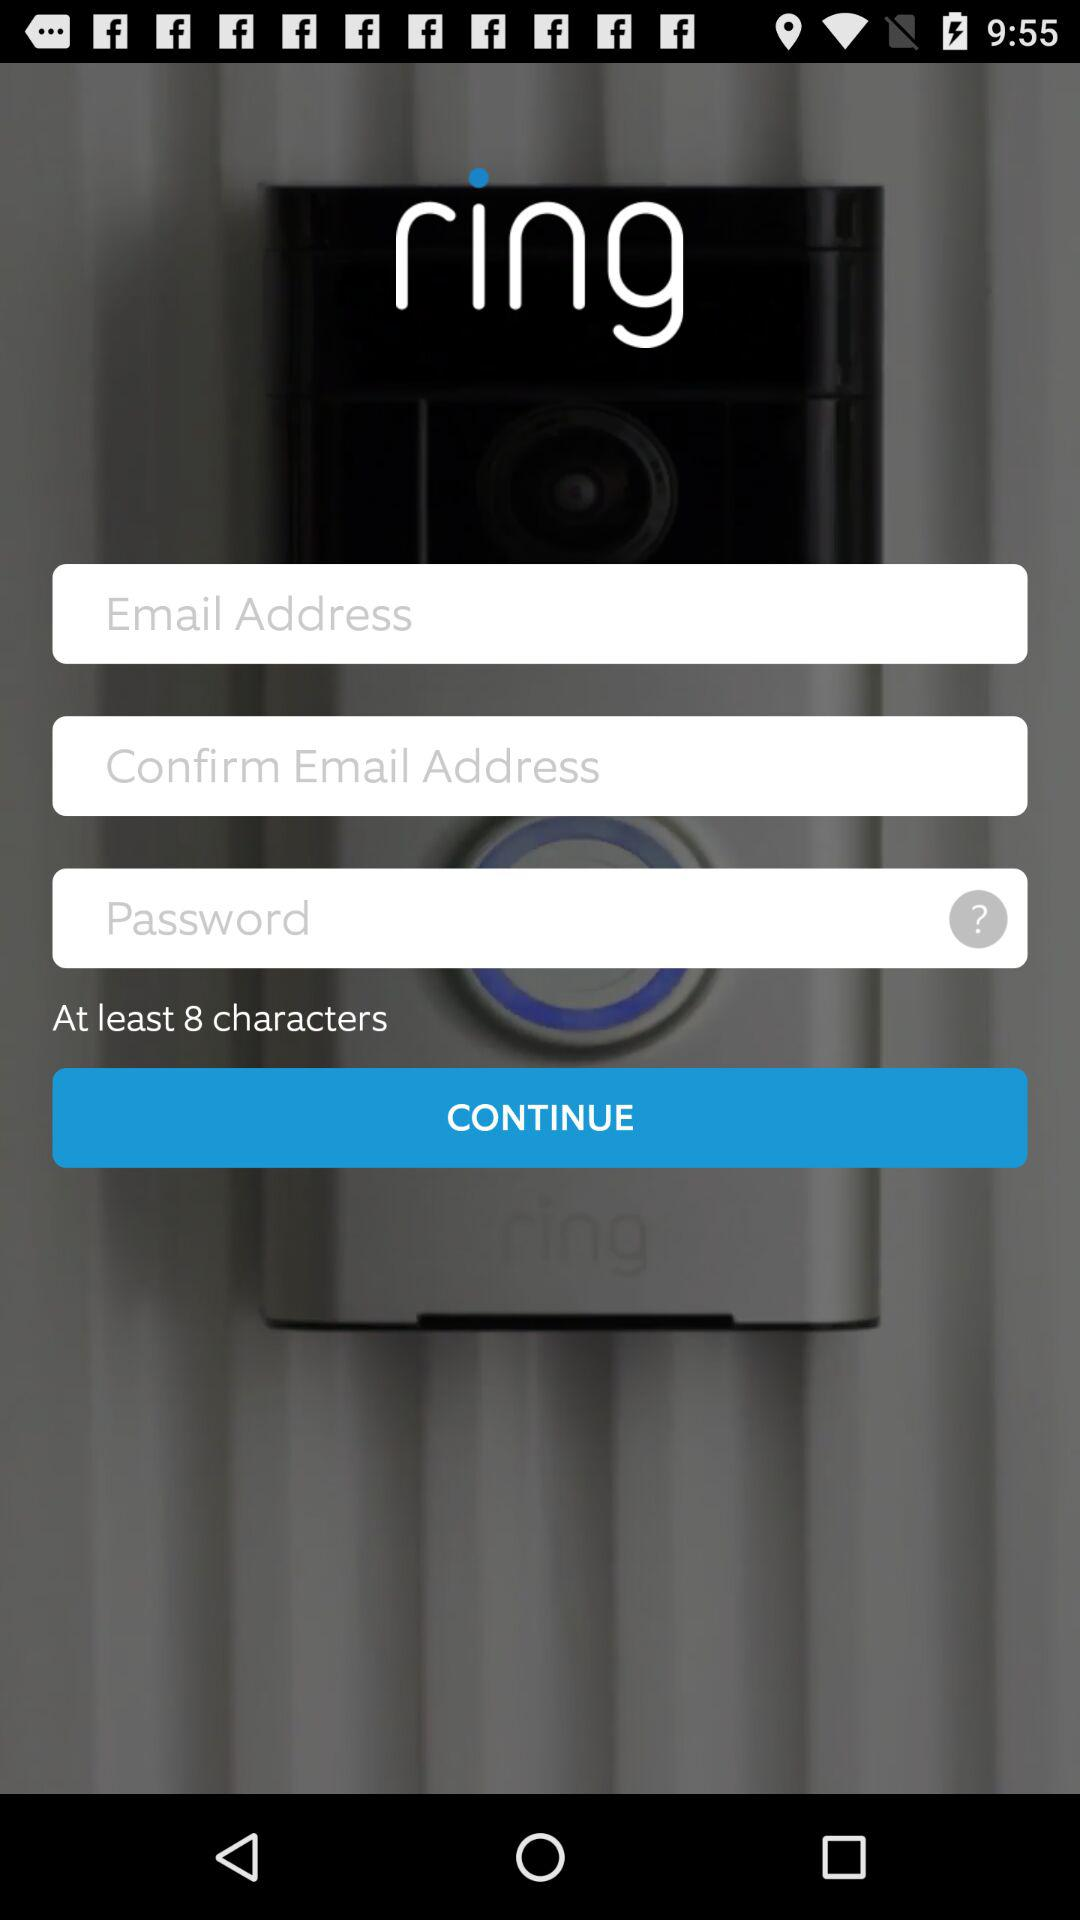What is the name of the application? The name of the application is "ring". 